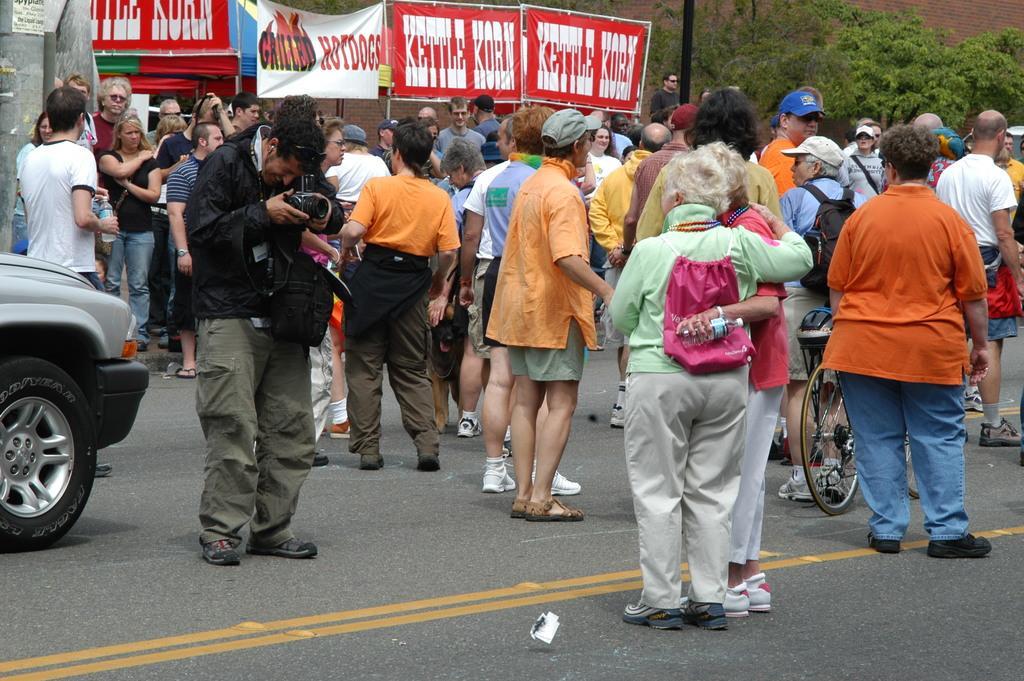Please provide a concise description of this image. In this image we can see some group of persons standing on road and there is a car, bicycle and in the background of the image there are some banners, trees. 